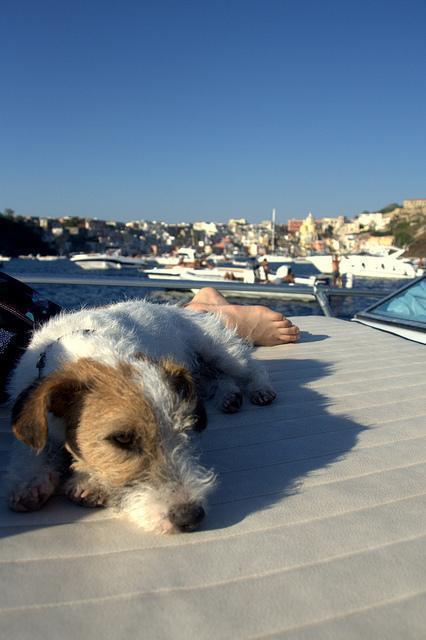How many elephants are there?
Give a very brief answer. 0. 